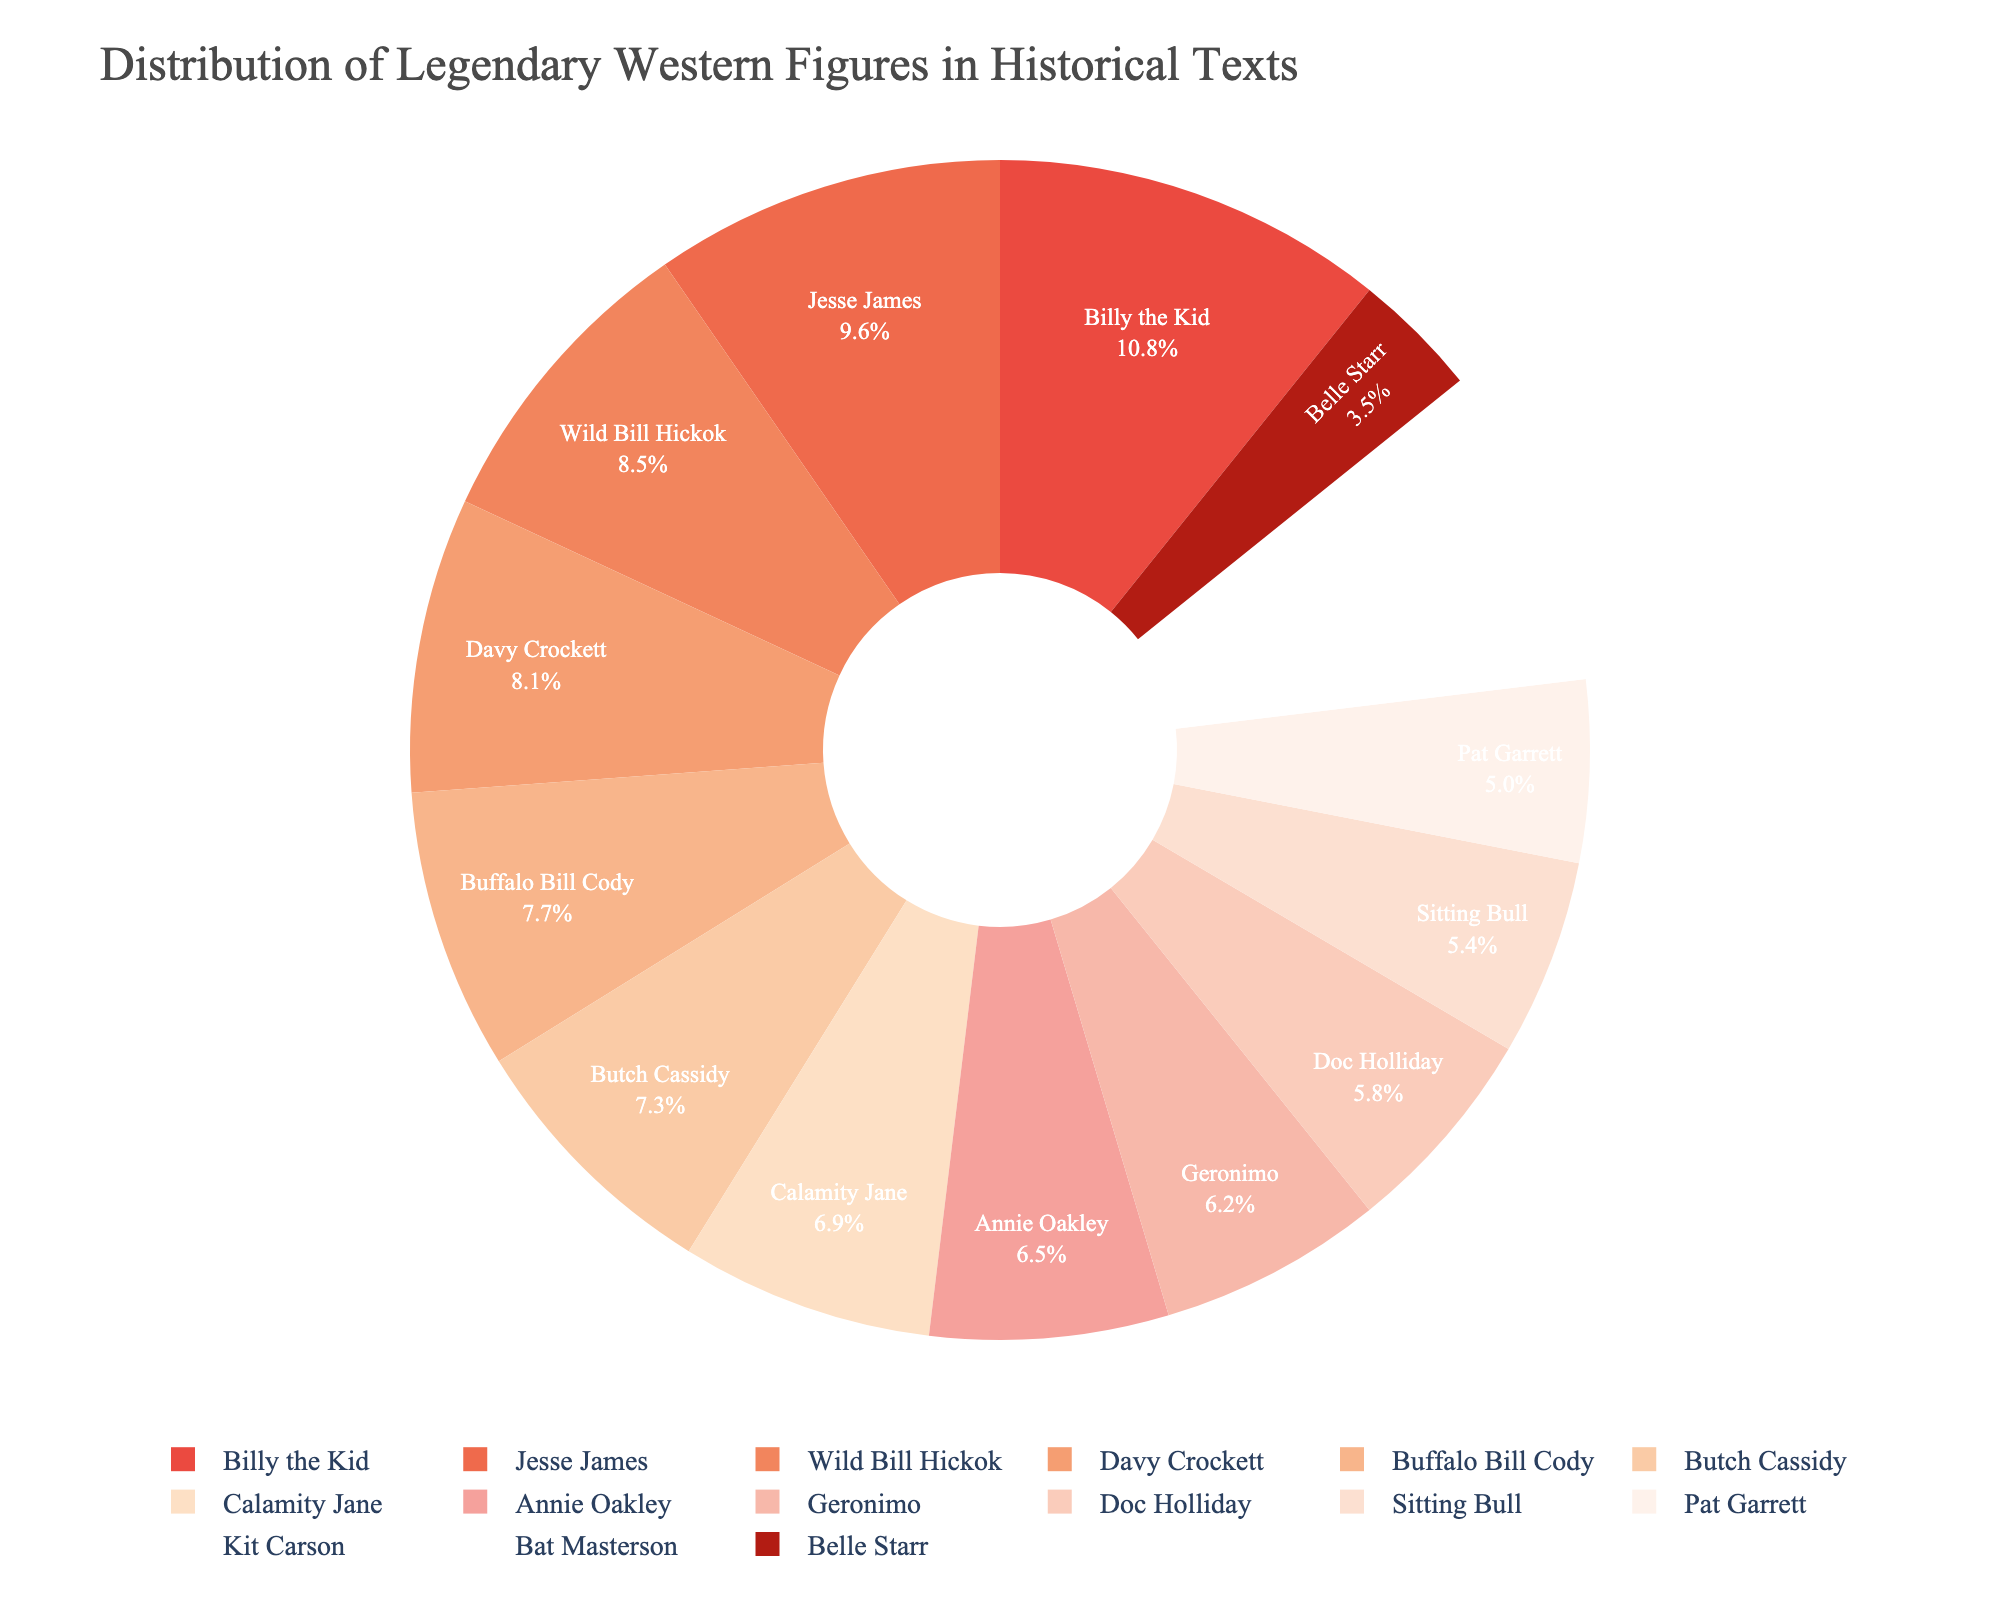Who has the highest number of mentions? The pie chart shows the distribution of mentions among various legendary Western figures. By identifying the largest segment, you can see that Billy the Kid has the highest number of mentions.
Answer: Billy the Kid Which two figures have a combined total of more mentions than Jesse James? Looking at the chart, we see the distribution percentages for each figure. Two segments that together make up more than Jesse James' share (about 16.7%) would need to be identified. Wild Bill Hickok (22 mentions) and Calamity Jane (18 mentions) together surpass Jesse James.
Answer: Wild Bill Hickok and Calamity Jane Which figure is mentioned more: Annie Oakley or Kit Carson? By comparing the segments for each figure in terms of size, Annie Oakley's segment is larger than Kit Carson's. This indicates she has more mentions.
Answer: Annie Oakley What is the difference in mentions between the figure with the most mentions and the figure with the least mentions? The chart indicates Billy the Kid has the most mentions at 28, while Belle Starr has the least at 9. The difference is 28 - 9 = 19.
Answer: 19 Which figures have a percentage of mentions close to 10%? Observing the segments' size relative to the whole pie, figures near 10% would have around 14-15 mentions. Doc Holliday and Sitting Bull fit this description.
Answer: Doc Holliday and Sitting Bull How does the mention count of Buffalo Bill Cody compare to that of Butch Cassidy? By comparing the sizes of their respective pie chart segments, we can see that Buffalo Bill Cody has 20 mentions while Butch Cassidy has 19. Therefore, Buffalo Bill Cody is mentioned more.
Answer: Buffalo Bill Cody How many more mentions does Davy Crockett have compared to Bat Masterson? The chart shows Davy Crockett with 21 mentions and Bat Masterson with 11. The difference is 21 - 11 = 10.
Answer: 10 What combined proportion of mentions do Geronimo and Pat Garrett have? Combining their segments, Geronimo has 16 mentions, and Pat Garrett has 13. Together this makes 29 mentions out of 240 total mentions, approximately 12.1%.
Answer: 12.1% Who has the second lowest mentions, and how many mentions do they have? By assessing the pie chart, the second smallest segment after Belle Starr (9 mentions) belongs to Bat Masterson with 11 mentions.
Answer: Bat Masterson What is the total number of mentions for all female figures combined? Reviewing the chart and summing mentions for Calamity Jane (18), Annie Oakley (17), and Belle Starr (9), the total number of mentions is 18 + 17 + 9 = 44.
Answer: 44 